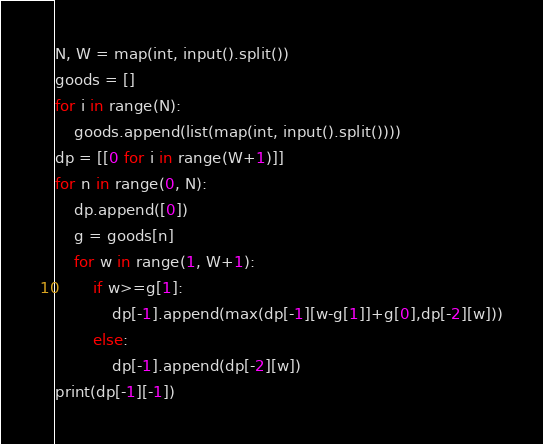<code> <loc_0><loc_0><loc_500><loc_500><_Python_>N, W = map(int, input().split())
goods = []
for i in range(N):
    goods.append(list(map(int, input().split())))
dp = [[0 for i in range(W+1)]]
for n in range(0, N):
    dp.append([0])
    g = goods[n]
    for w in range(1, W+1):
        if w>=g[1]:
            dp[-1].append(max(dp[-1][w-g[1]]+g[0],dp[-2][w]))
        else:
            dp[-1].append(dp[-2][w])
print(dp[-1][-1])
</code> 